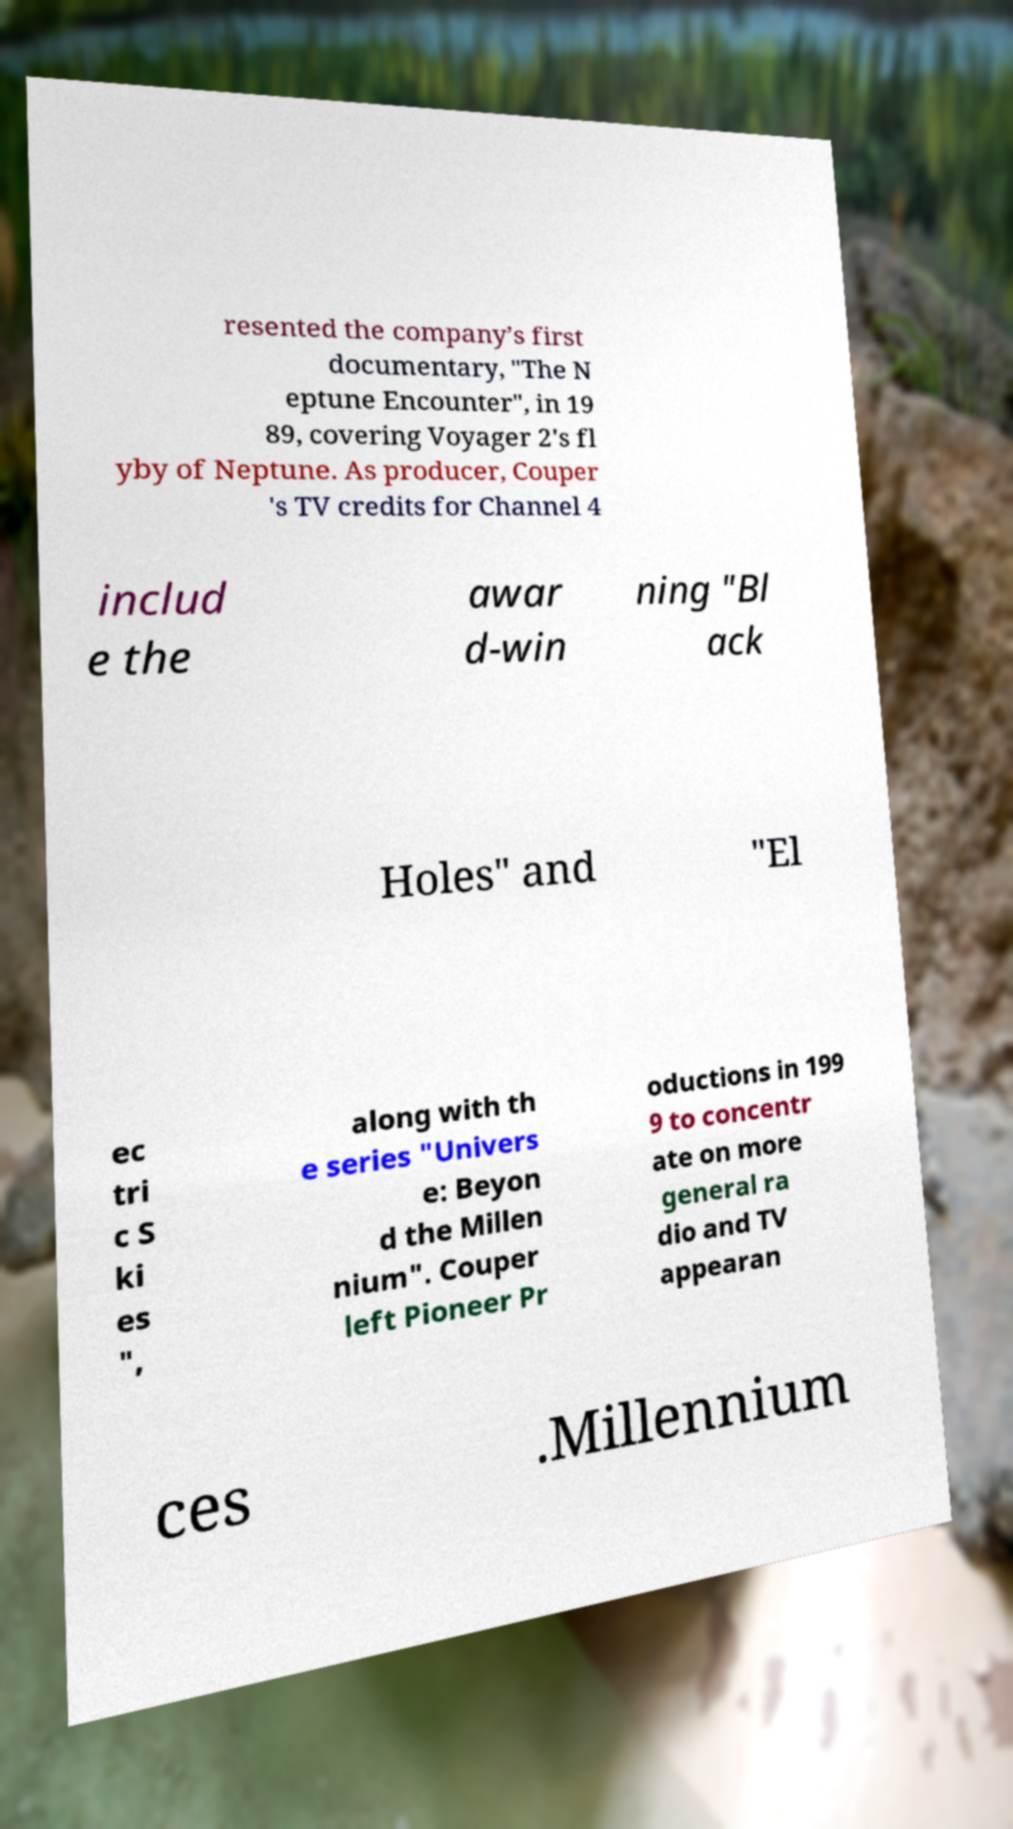Please identify and transcribe the text found in this image. resented the company’s first documentary, "The N eptune Encounter", in 19 89, covering Voyager 2's fl yby of Neptune. As producer, Couper 's TV credits for Channel 4 includ e the awar d-win ning "Bl ack Holes" and "El ec tri c S ki es ", along with th e series "Univers e: Beyon d the Millen nium". Couper left Pioneer Pr oductions in 199 9 to concentr ate on more general ra dio and TV appearan ces .Millennium 